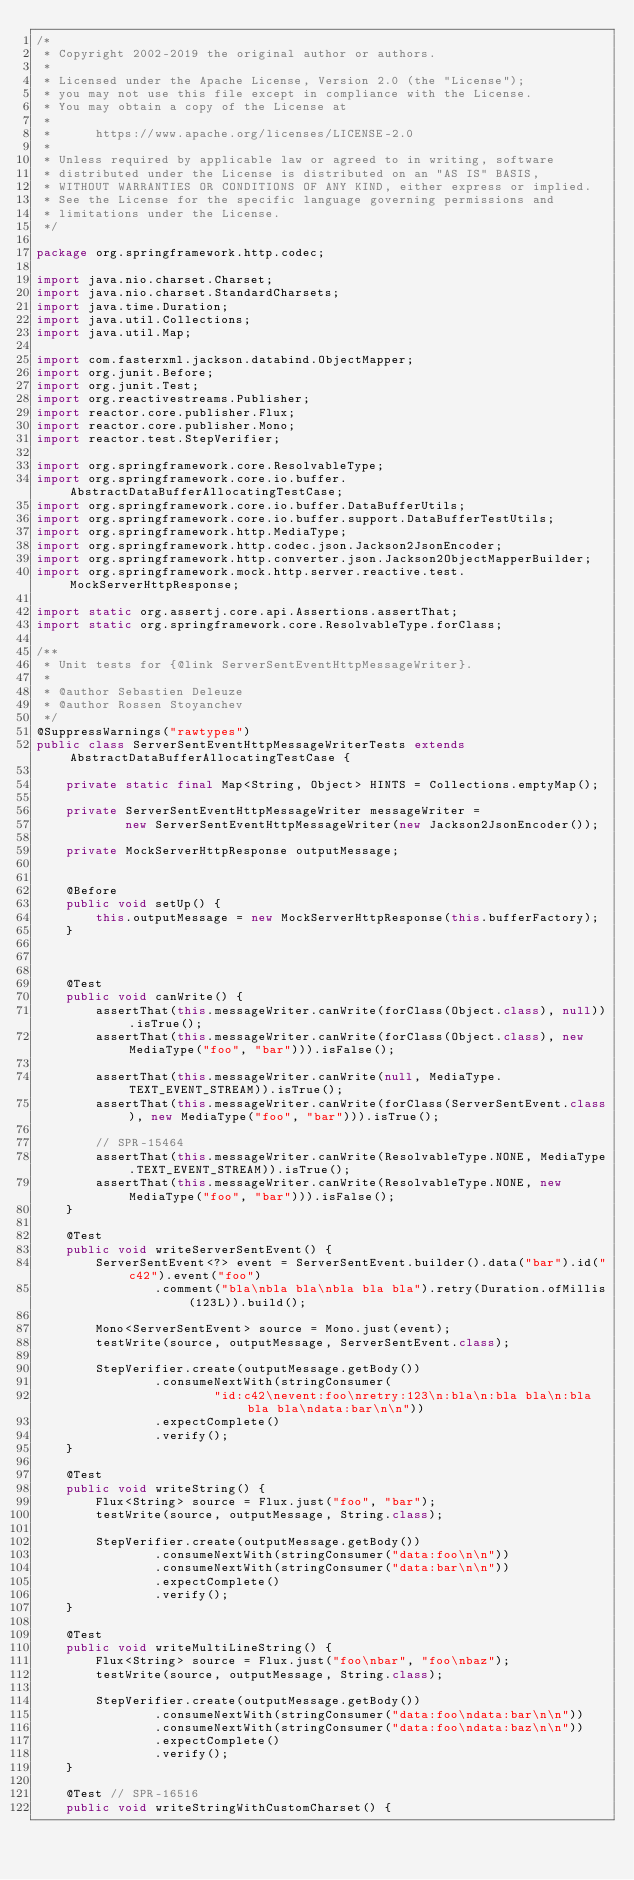<code> <loc_0><loc_0><loc_500><loc_500><_Java_>/*
 * Copyright 2002-2019 the original author or authors.
 *
 * Licensed under the Apache License, Version 2.0 (the "License");
 * you may not use this file except in compliance with the License.
 * You may obtain a copy of the License at
 *
 *      https://www.apache.org/licenses/LICENSE-2.0
 *
 * Unless required by applicable law or agreed to in writing, software
 * distributed under the License is distributed on an "AS IS" BASIS,
 * WITHOUT WARRANTIES OR CONDITIONS OF ANY KIND, either express or implied.
 * See the License for the specific language governing permissions and
 * limitations under the License.
 */

package org.springframework.http.codec;

import java.nio.charset.Charset;
import java.nio.charset.StandardCharsets;
import java.time.Duration;
import java.util.Collections;
import java.util.Map;

import com.fasterxml.jackson.databind.ObjectMapper;
import org.junit.Before;
import org.junit.Test;
import org.reactivestreams.Publisher;
import reactor.core.publisher.Flux;
import reactor.core.publisher.Mono;
import reactor.test.StepVerifier;

import org.springframework.core.ResolvableType;
import org.springframework.core.io.buffer.AbstractDataBufferAllocatingTestCase;
import org.springframework.core.io.buffer.DataBufferUtils;
import org.springframework.core.io.buffer.support.DataBufferTestUtils;
import org.springframework.http.MediaType;
import org.springframework.http.codec.json.Jackson2JsonEncoder;
import org.springframework.http.converter.json.Jackson2ObjectMapperBuilder;
import org.springframework.mock.http.server.reactive.test.MockServerHttpResponse;

import static org.assertj.core.api.Assertions.assertThat;
import static org.springframework.core.ResolvableType.forClass;

/**
 * Unit tests for {@link ServerSentEventHttpMessageWriter}.
 *
 * @author Sebastien Deleuze
 * @author Rossen Stoyanchev
 */
@SuppressWarnings("rawtypes")
public class ServerSentEventHttpMessageWriterTests extends AbstractDataBufferAllocatingTestCase {

	private static final Map<String, Object> HINTS = Collections.emptyMap();

	private ServerSentEventHttpMessageWriter messageWriter =
			new ServerSentEventHttpMessageWriter(new Jackson2JsonEncoder());

	private MockServerHttpResponse outputMessage;


	@Before
	public void setUp() {
		this.outputMessage = new MockServerHttpResponse(this.bufferFactory);
	}



	@Test
	public void canWrite() {
		assertThat(this.messageWriter.canWrite(forClass(Object.class), null)).isTrue();
		assertThat(this.messageWriter.canWrite(forClass(Object.class), new MediaType("foo", "bar"))).isFalse();

		assertThat(this.messageWriter.canWrite(null, MediaType.TEXT_EVENT_STREAM)).isTrue();
		assertThat(this.messageWriter.canWrite(forClass(ServerSentEvent.class), new MediaType("foo", "bar"))).isTrue();

		// SPR-15464
		assertThat(this.messageWriter.canWrite(ResolvableType.NONE, MediaType.TEXT_EVENT_STREAM)).isTrue();
		assertThat(this.messageWriter.canWrite(ResolvableType.NONE, new MediaType("foo", "bar"))).isFalse();
	}

	@Test
	public void writeServerSentEvent() {
		ServerSentEvent<?> event = ServerSentEvent.builder().data("bar").id("c42").event("foo")
				.comment("bla\nbla bla\nbla bla bla").retry(Duration.ofMillis(123L)).build();

		Mono<ServerSentEvent> source = Mono.just(event);
		testWrite(source, outputMessage, ServerSentEvent.class);

		StepVerifier.create(outputMessage.getBody())
				.consumeNextWith(stringConsumer(
						"id:c42\nevent:foo\nretry:123\n:bla\n:bla bla\n:bla bla bla\ndata:bar\n\n"))
				.expectComplete()
				.verify();
	}

	@Test
	public void writeString() {
		Flux<String> source = Flux.just("foo", "bar");
		testWrite(source, outputMessage, String.class);

		StepVerifier.create(outputMessage.getBody())
				.consumeNextWith(stringConsumer("data:foo\n\n"))
				.consumeNextWith(stringConsumer("data:bar\n\n"))
				.expectComplete()
				.verify();
	}

	@Test
	public void writeMultiLineString() {
		Flux<String> source = Flux.just("foo\nbar", "foo\nbaz");
		testWrite(source, outputMessage, String.class);

		StepVerifier.create(outputMessage.getBody())
				.consumeNextWith(stringConsumer("data:foo\ndata:bar\n\n"))
				.consumeNextWith(stringConsumer("data:foo\ndata:baz\n\n"))
				.expectComplete()
				.verify();
	}

	@Test // SPR-16516
	public void writeStringWithCustomCharset() {</code> 